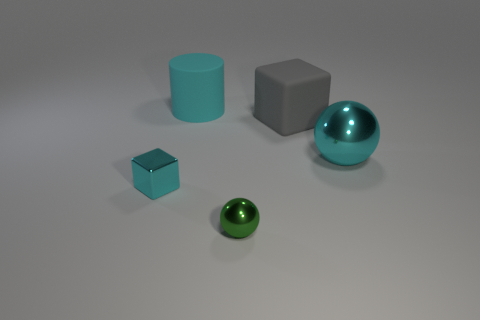Subtract all cyan blocks. How many blocks are left? 1 Subtract all cylinders. How many objects are left? 4 Add 3 tiny red shiny cubes. How many objects exist? 8 Subtract 1 cylinders. How many cylinders are left? 0 Subtract all cyan blocks. How many purple cylinders are left? 0 Subtract all purple cubes. Subtract all small green shiny objects. How many objects are left? 4 Add 5 large gray rubber blocks. How many large gray rubber blocks are left? 6 Add 3 cyan rubber objects. How many cyan rubber objects exist? 4 Subtract 1 cyan cylinders. How many objects are left? 4 Subtract all brown cylinders. Subtract all gray cubes. How many cylinders are left? 1 